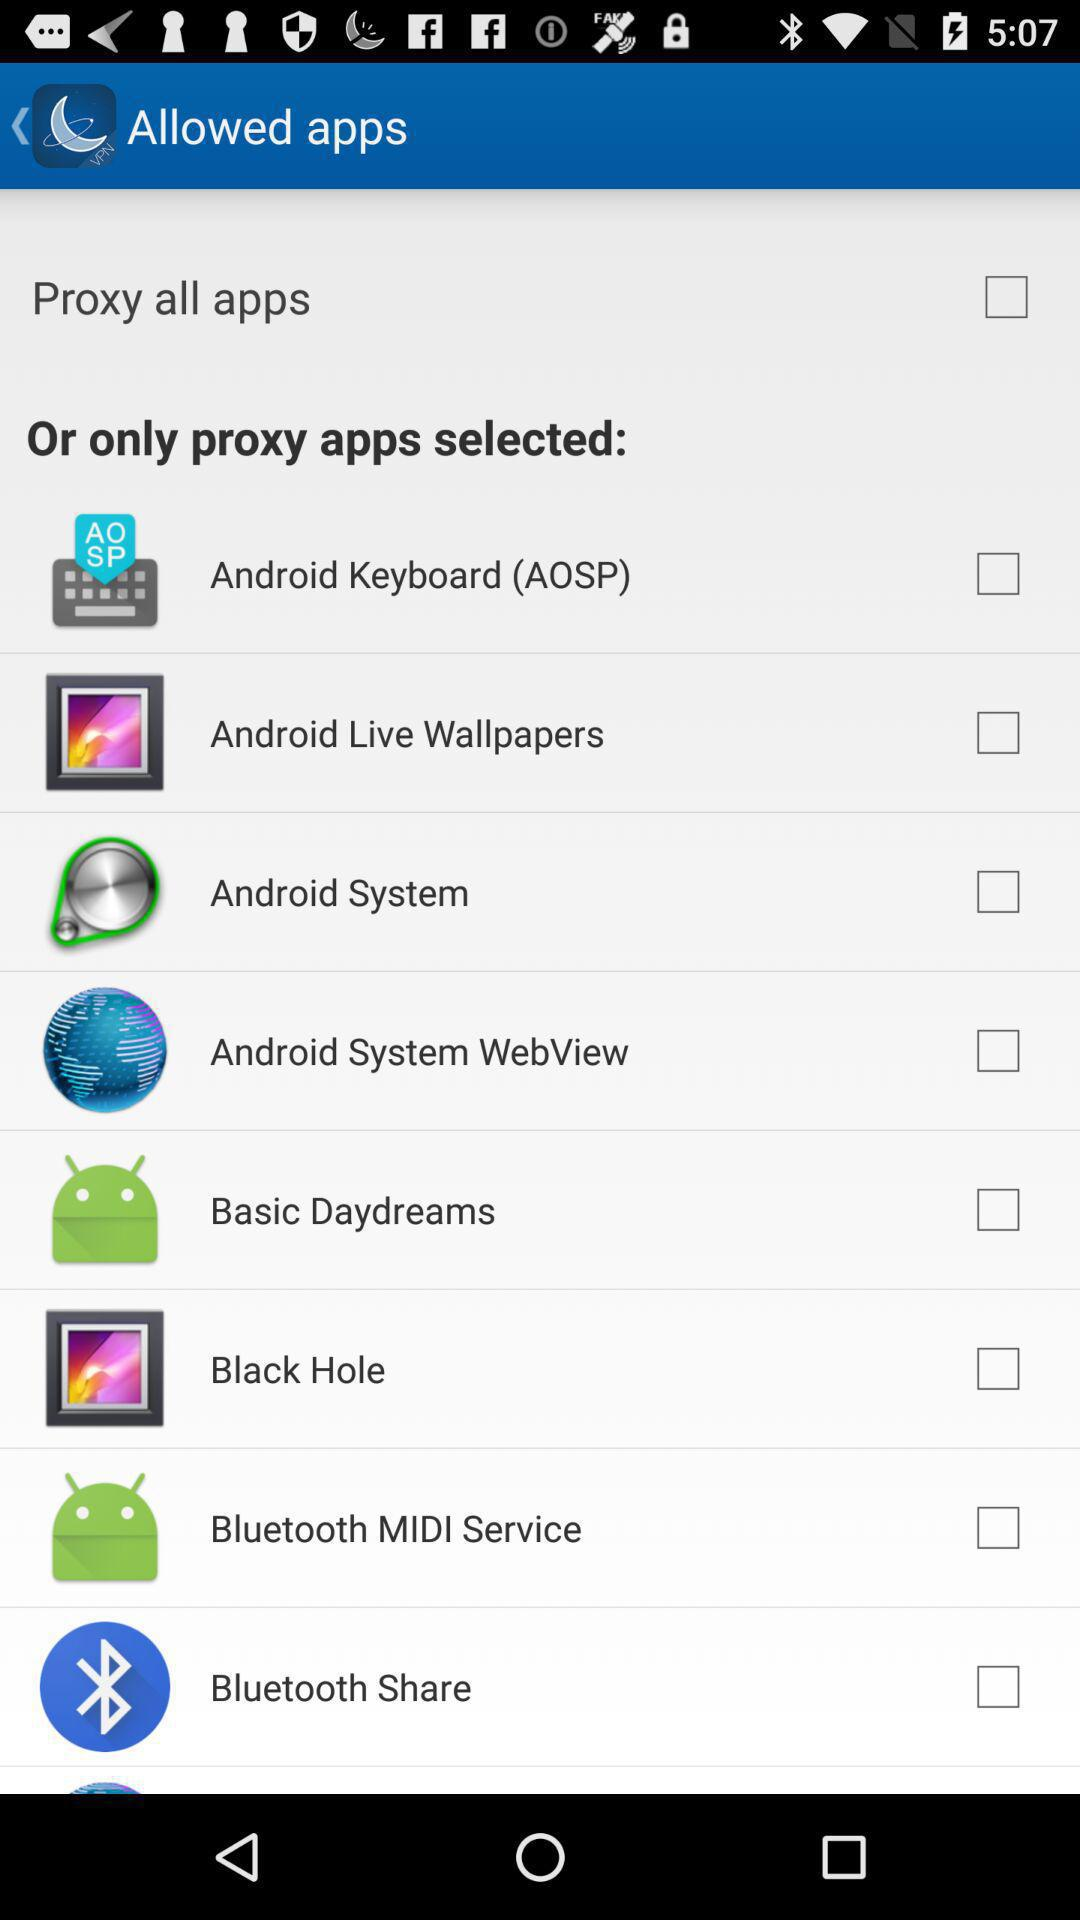What is the status of the "Proxy all apps" setting? The status is "off". 